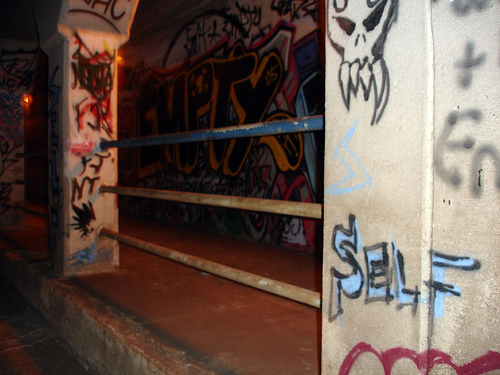<image>
Can you confirm if the railing is on the floor? No. The railing is not positioned on the floor. They may be near each other, but the railing is not supported by or resting on top of the floor. 